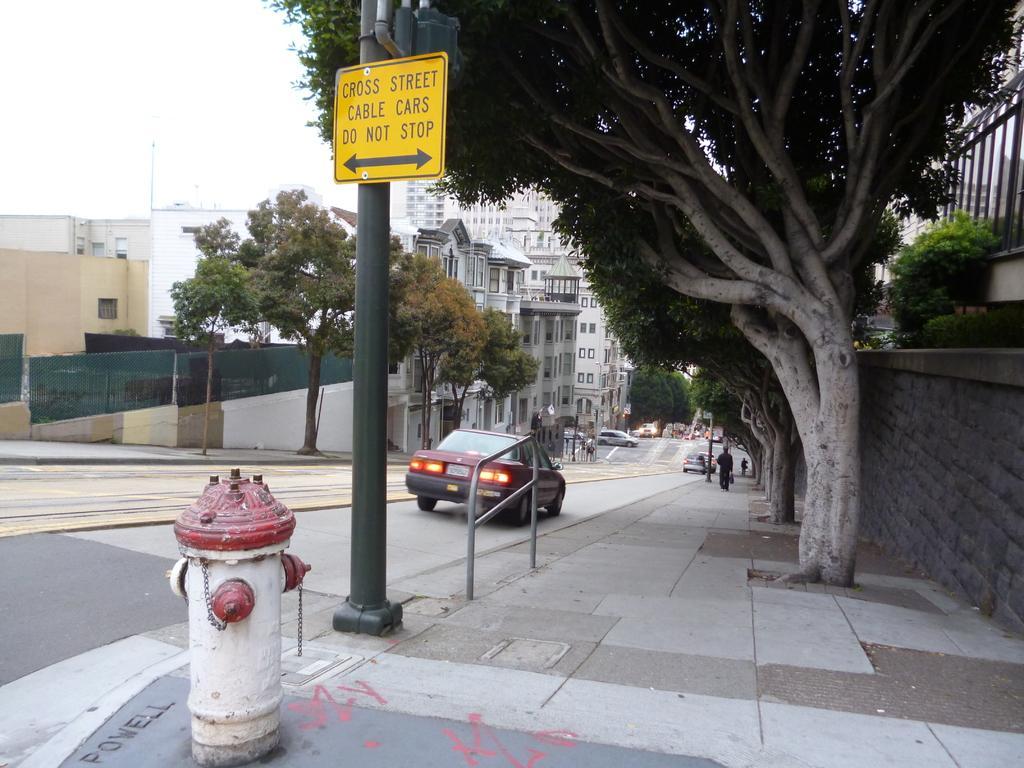Describe this image in one or two sentences. This is a picture of the outside of a city, in this picture in the center there is one pole and one board and there is one fire extinguisher. On the right side and left side there are some trees houses and buildings, and at the bottom there is a road. On the road there are some vehicles and on the right side there is a footpath, on the footpath there is one person who is walking. 